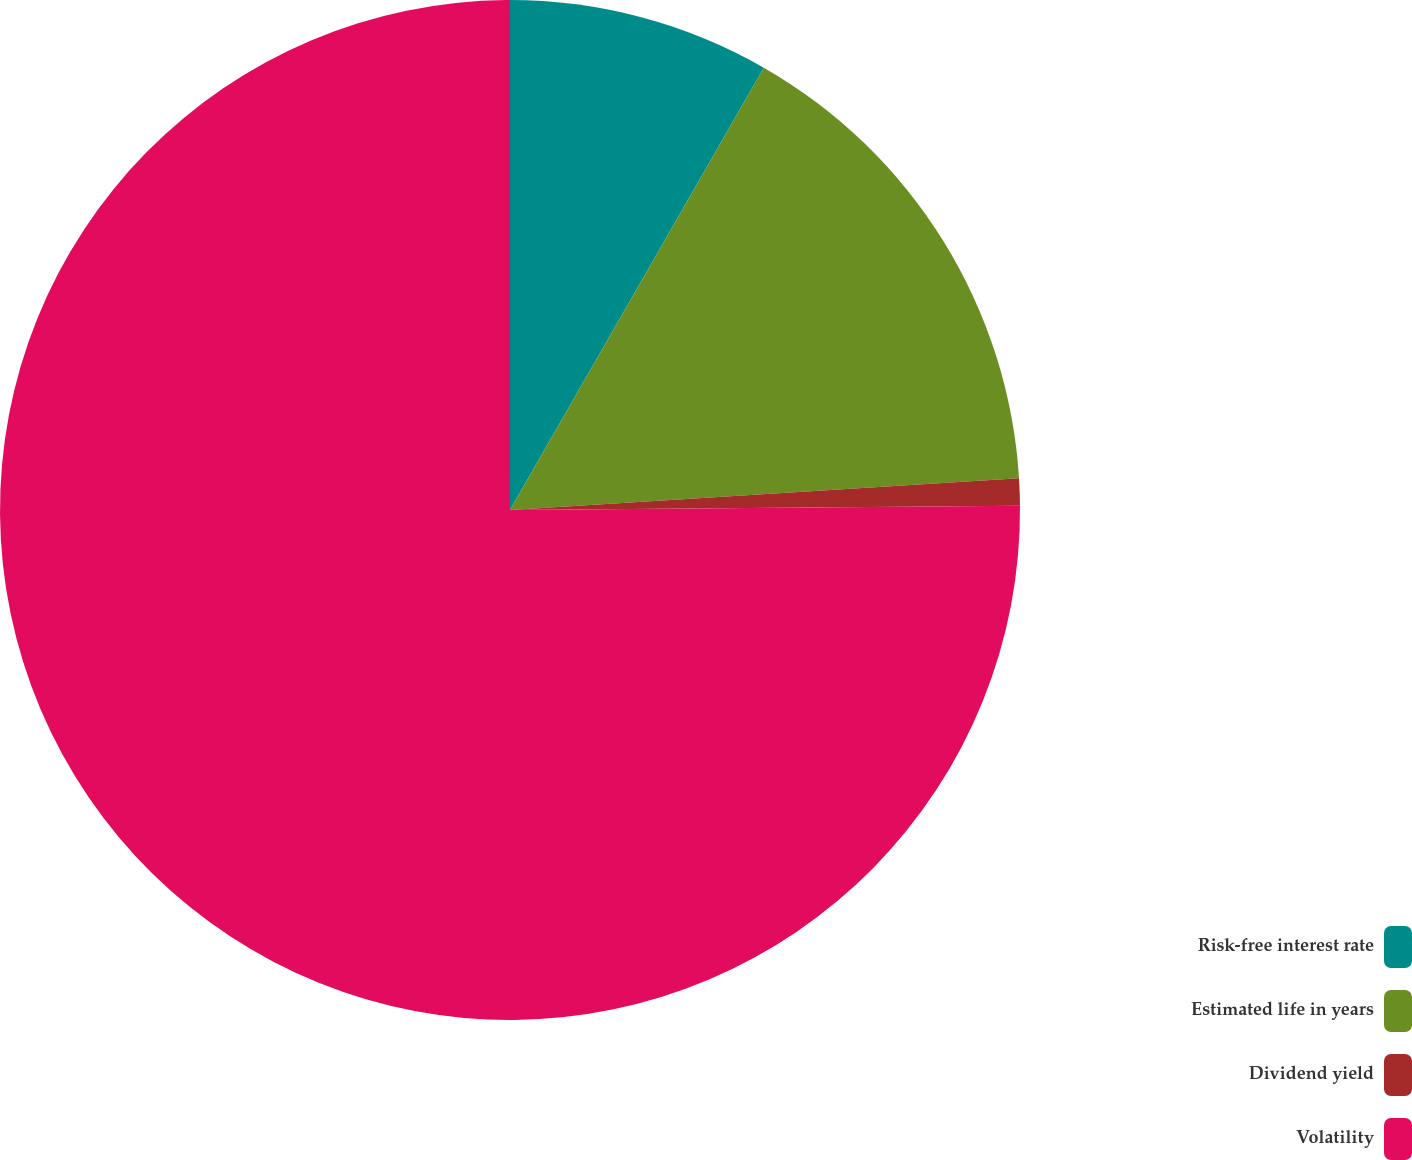Convert chart. <chart><loc_0><loc_0><loc_500><loc_500><pie_chart><fcel>Risk-free interest rate<fcel>Estimated life in years<fcel>Dividend yield<fcel>Volatility<nl><fcel>8.29%<fcel>15.72%<fcel>0.86%<fcel>75.13%<nl></chart> 